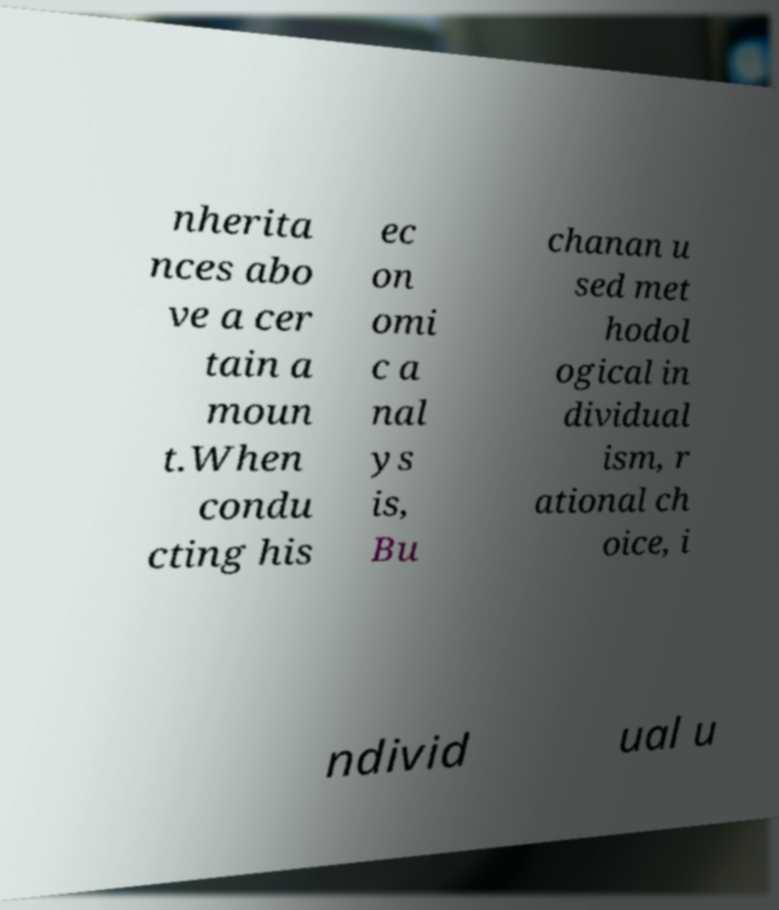Could you extract and type out the text from this image? nherita nces abo ve a cer tain a moun t.When condu cting his ec on omi c a nal ys is, Bu chanan u sed met hodol ogical in dividual ism, r ational ch oice, i ndivid ual u 